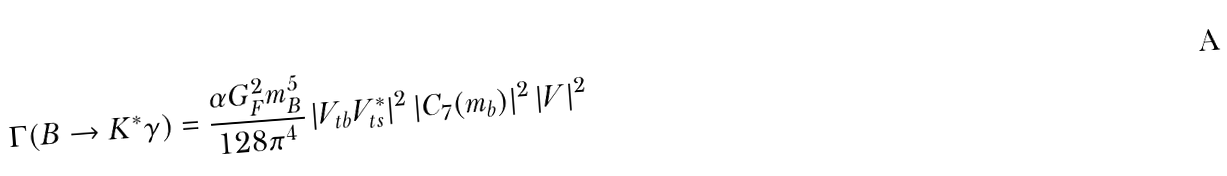Convert formula to latex. <formula><loc_0><loc_0><loc_500><loc_500>\Gamma ( B \rightarrow K ^ { * } \gamma ) = \frac { \alpha G _ { F } ^ { 2 } m _ { B } ^ { 5 } } { 1 2 8 \pi ^ { 4 } } \, | V _ { t b } V _ { t s } ^ { * } | ^ { 2 } \, | C _ { 7 } ( m _ { b } ) | ^ { 2 } \, | V | ^ { 2 }</formula> 